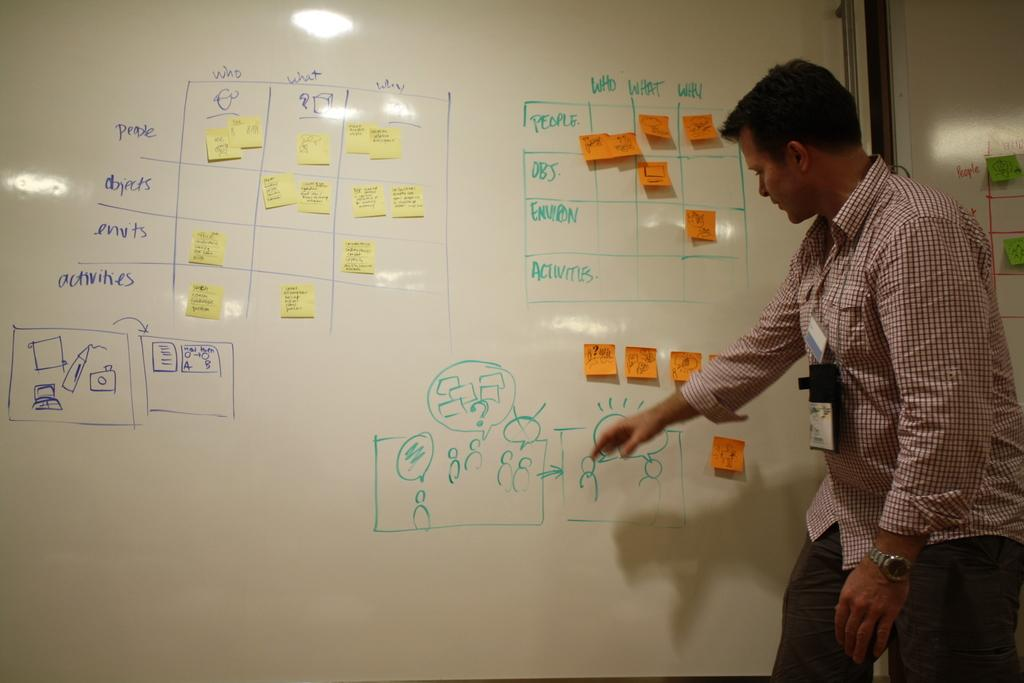Provide a one-sentence caption for the provided image. Man giving a presentation on a white board that reads "Who,What,Why" at the top. 